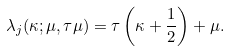<formula> <loc_0><loc_0><loc_500><loc_500>\lambda _ { j } ( \kappa ; \mu , \tau \mu ) = \tau \left ( \kappa + \frac { 1 } { 2 } \right ) + \mu .</formula> 